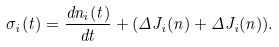<formula> <loc_0><loc_0><loc_500><loc_500>\sigma _ { i } ( t ) = \frac { d n _ { i } ( t ) } { d t } + ( \Delta { J _ { i } } ( { n } ) + \Delta { J _ { i } } ( { n } ) ) .</formula> 